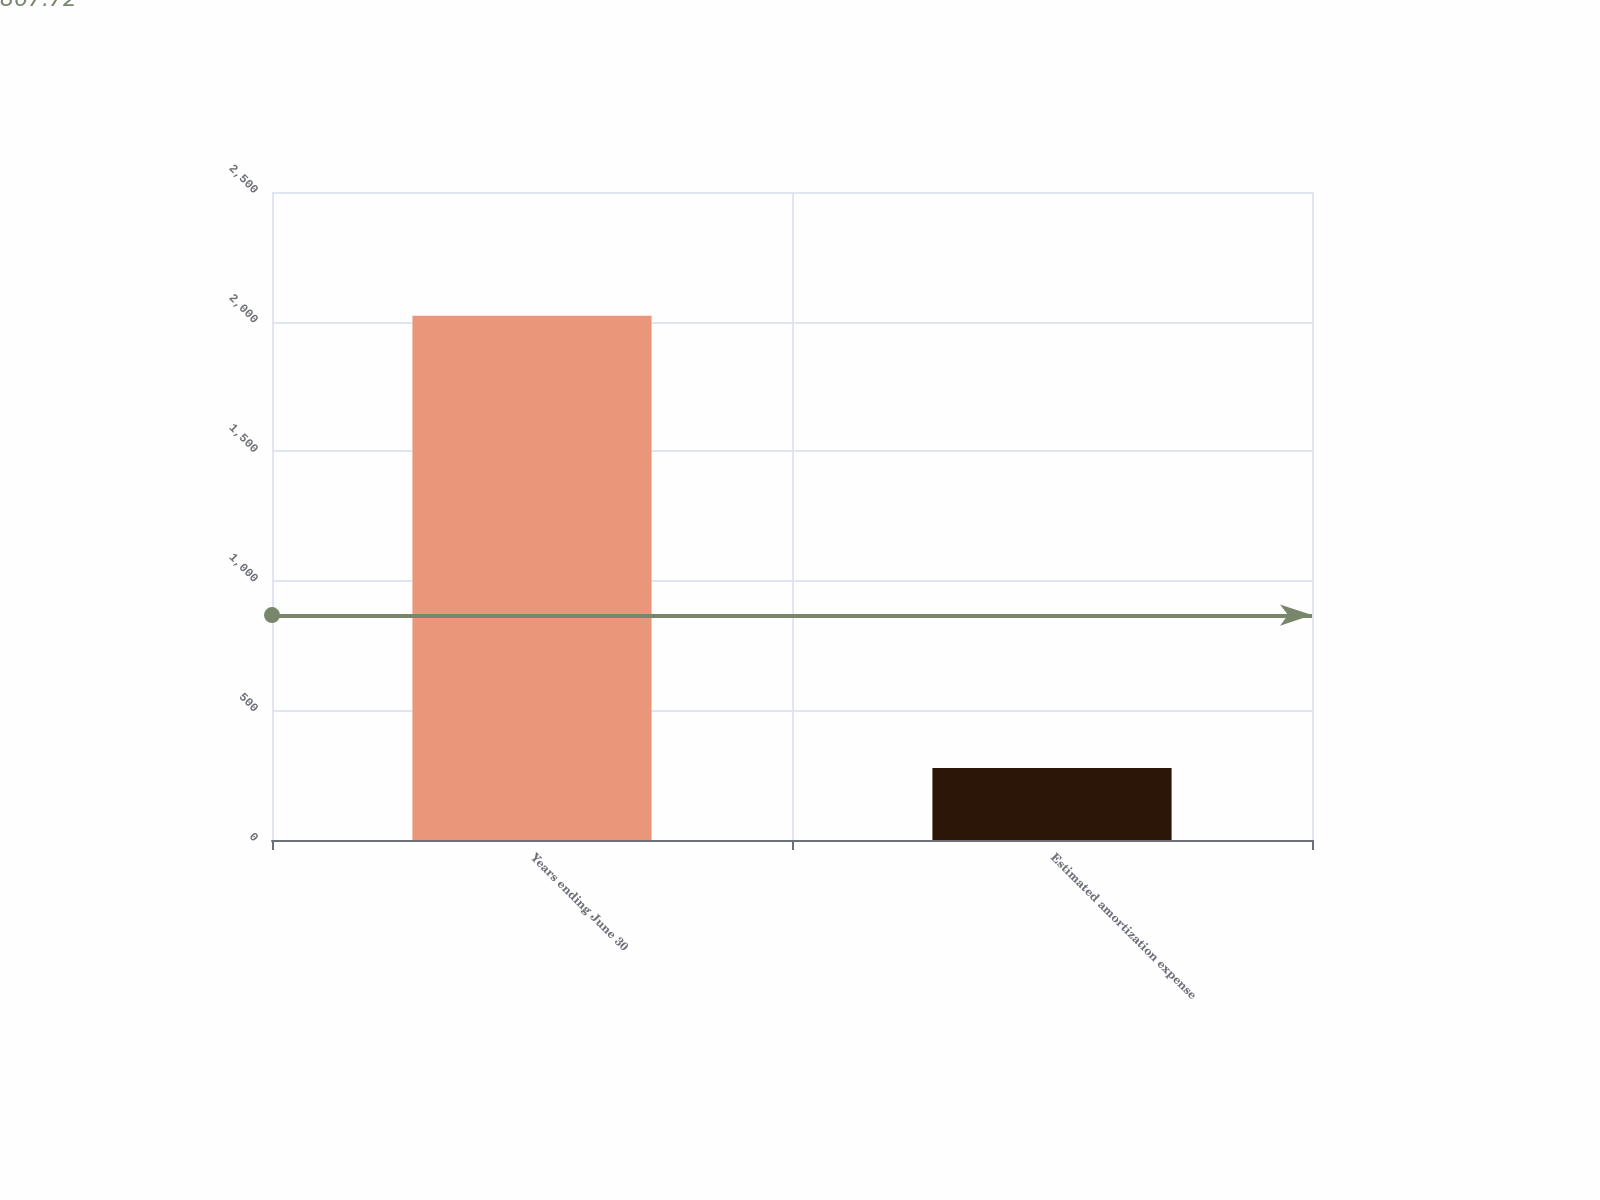<chart> <loc_0><loc_0><loc_500><loc_500><bar_chart><fcel>Years ending June 30<fcel>Estimated amortization expense<nl><fcel>2023<fcel>278<nl></chart> 